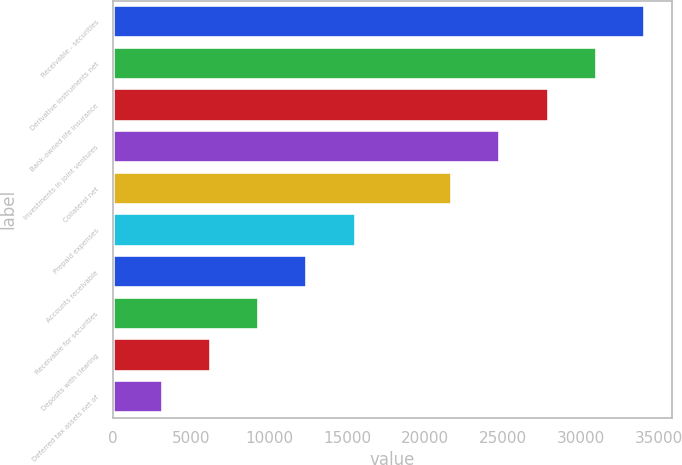<chart> <loc_0><loc_0><loc_500><loc_500><bar_chart><fcel>Receivable - securities<fcel>Derivative instruments net<fcel>Bank-owned life insurance<fcel>Investments in joint ventures<fcel>Collateral net<fcel>Prepaid expenses<fcel>Accounts receivable<fcel>Receivable for securities<fcel>Deposits with clearing<fcel>Deferred tax assets net of<nl><fcel>34110.1<fcel>31018<fcel>27925.9<fcel>24833.8<fcel>21741.7<fcel>15557.5<fcel>12465.4<fcel>9373.3<fcel>6281.2<fcel>3189.1<nl></chart> 